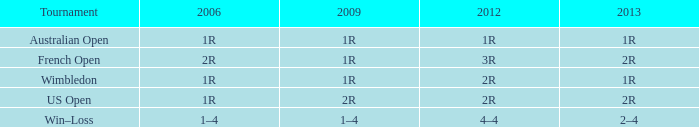What is the 2006 when the 2013 is 2r, and a competition was the us open? 1R. 